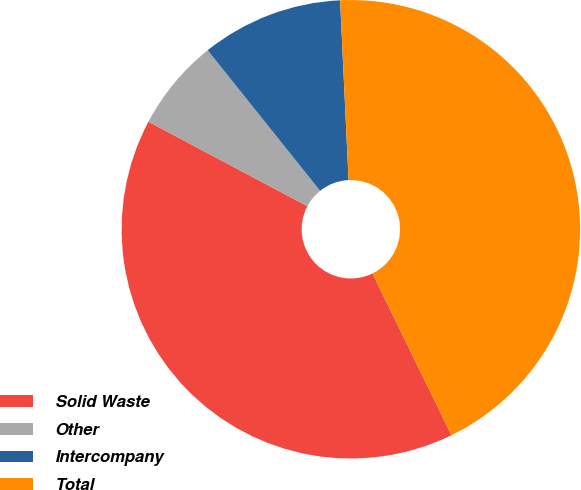Convert chart. <chart><loc_0><loc_0><loc_500><loc_500><pie_chart><fcel>Solid Waste<fcel>Other<fcel>Intercompany<fcel>Total<nl><fcel>40.01%<fcel>6.49%<fcel>9.99%<fcel>43.51%<nl></chart> 